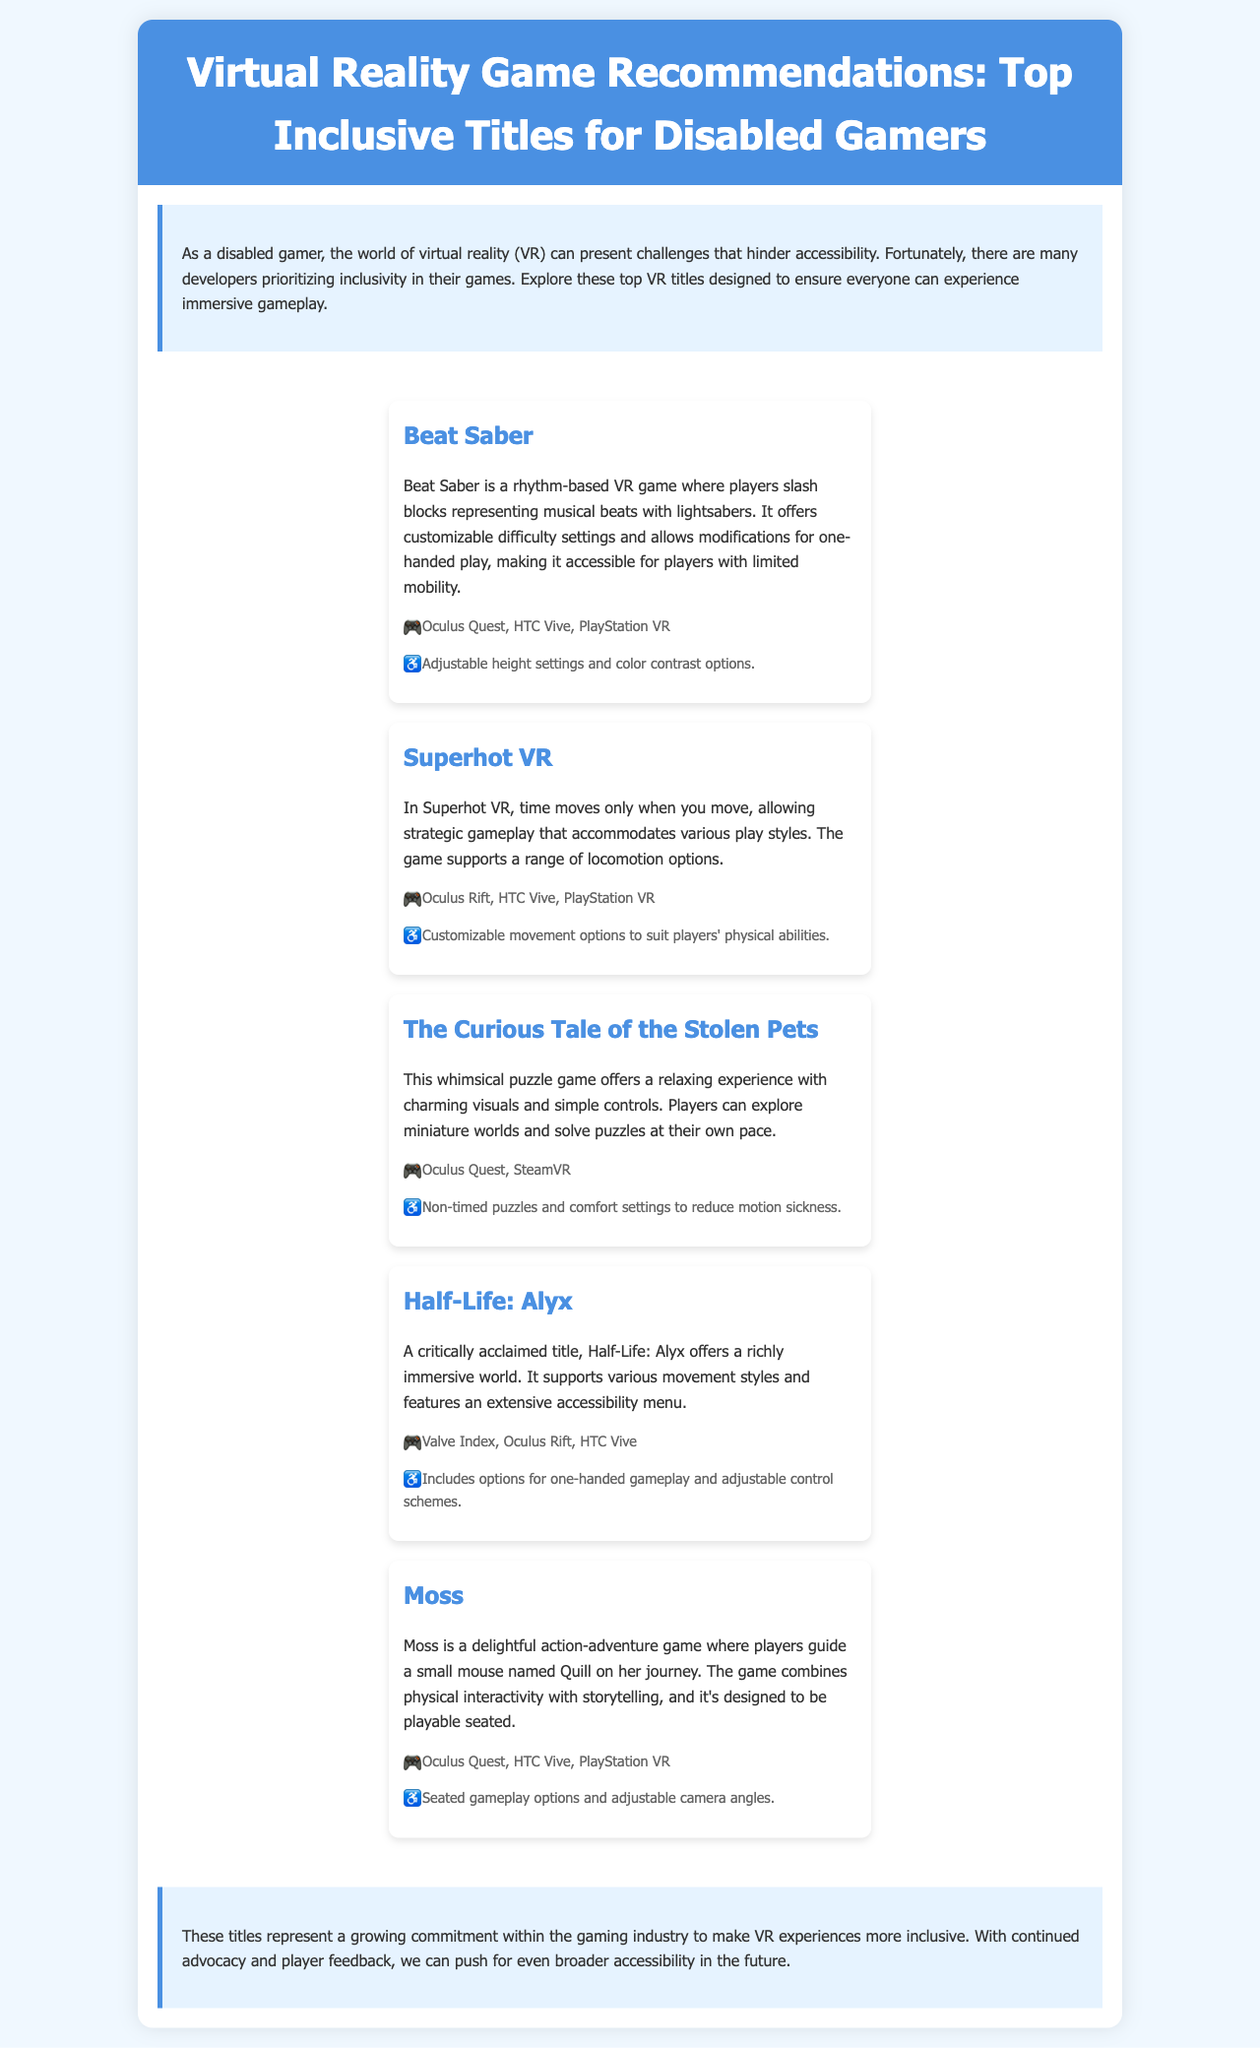what is the title of the brochure? The title of the brochure is prominently displayed at the top and is "Virtual Reality Game Recommendations: Top Inclusive Titles for Disabled Gamers."
Answer: Virtual Reality Game Recommendations: Top Inclusive Titles for Disabled Gamers how many games are recommended in the document? The document lists a total of five games aimed at disabled gamers.
Answer: 5 which game features customizable movement options? The document specifies that Superhot VR supports customizable movement options to suit players' physical abilities.
Answer: Superhot VR what platforms is Beat Saber available on? The document provides a list of platforms where Beat Saber can be played, including Oculus Quest, HTC Vive, and PlayStation VR.
Answer: Oculus Quest, HTC Vive, PlayStation VR what accessibility feature does Moss include? Moss offers seated gameplay options and adjustable camera angles, as stated in the accessibility section.
Answer: Seated gameplay options and adjustable camera angles which game is described as a whimsical puzzle game? The description in the document indicates that The Curious Tale of the Stolen Pets is a whimsical puzzle game.
Answer: The Curious Tale of the Stolen Pets what is the conclusion about the gaming industry in the document? The conclusion emphasizes a growing commitment to inclusivity in VR gaming and encourages continued advocacy and player feedback for better accessibility.
Answer: Commitment to inclusivity which game is known for its immersive world? Half-Life: Alyx is highlighted in the document as offering a richly immersive world.
Answer: Half-Life: Alyx 